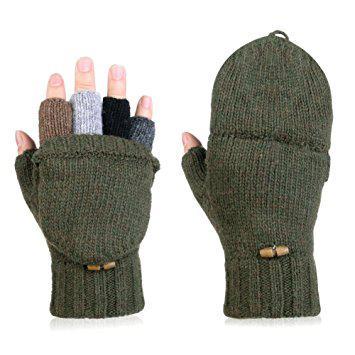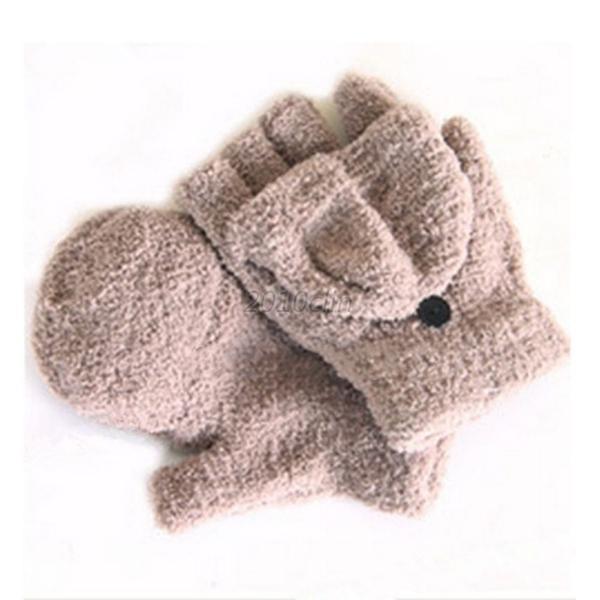The first image is the image on the left, the second image is the image on the right. For the images shown, is this caption "The left image shows a pair of pink half-finger gloves with a mitten flap, and the right shows the same type of fashion in heather yarn, but only one shows gloves worn by hands." true? Answer yes or no. No. The first image is the image on the left, the second image is the image on the right. Assess this claim about the two images: "There is a set of pink convertible mittens in one image.". Correct or not? Answer yes or no. No. 